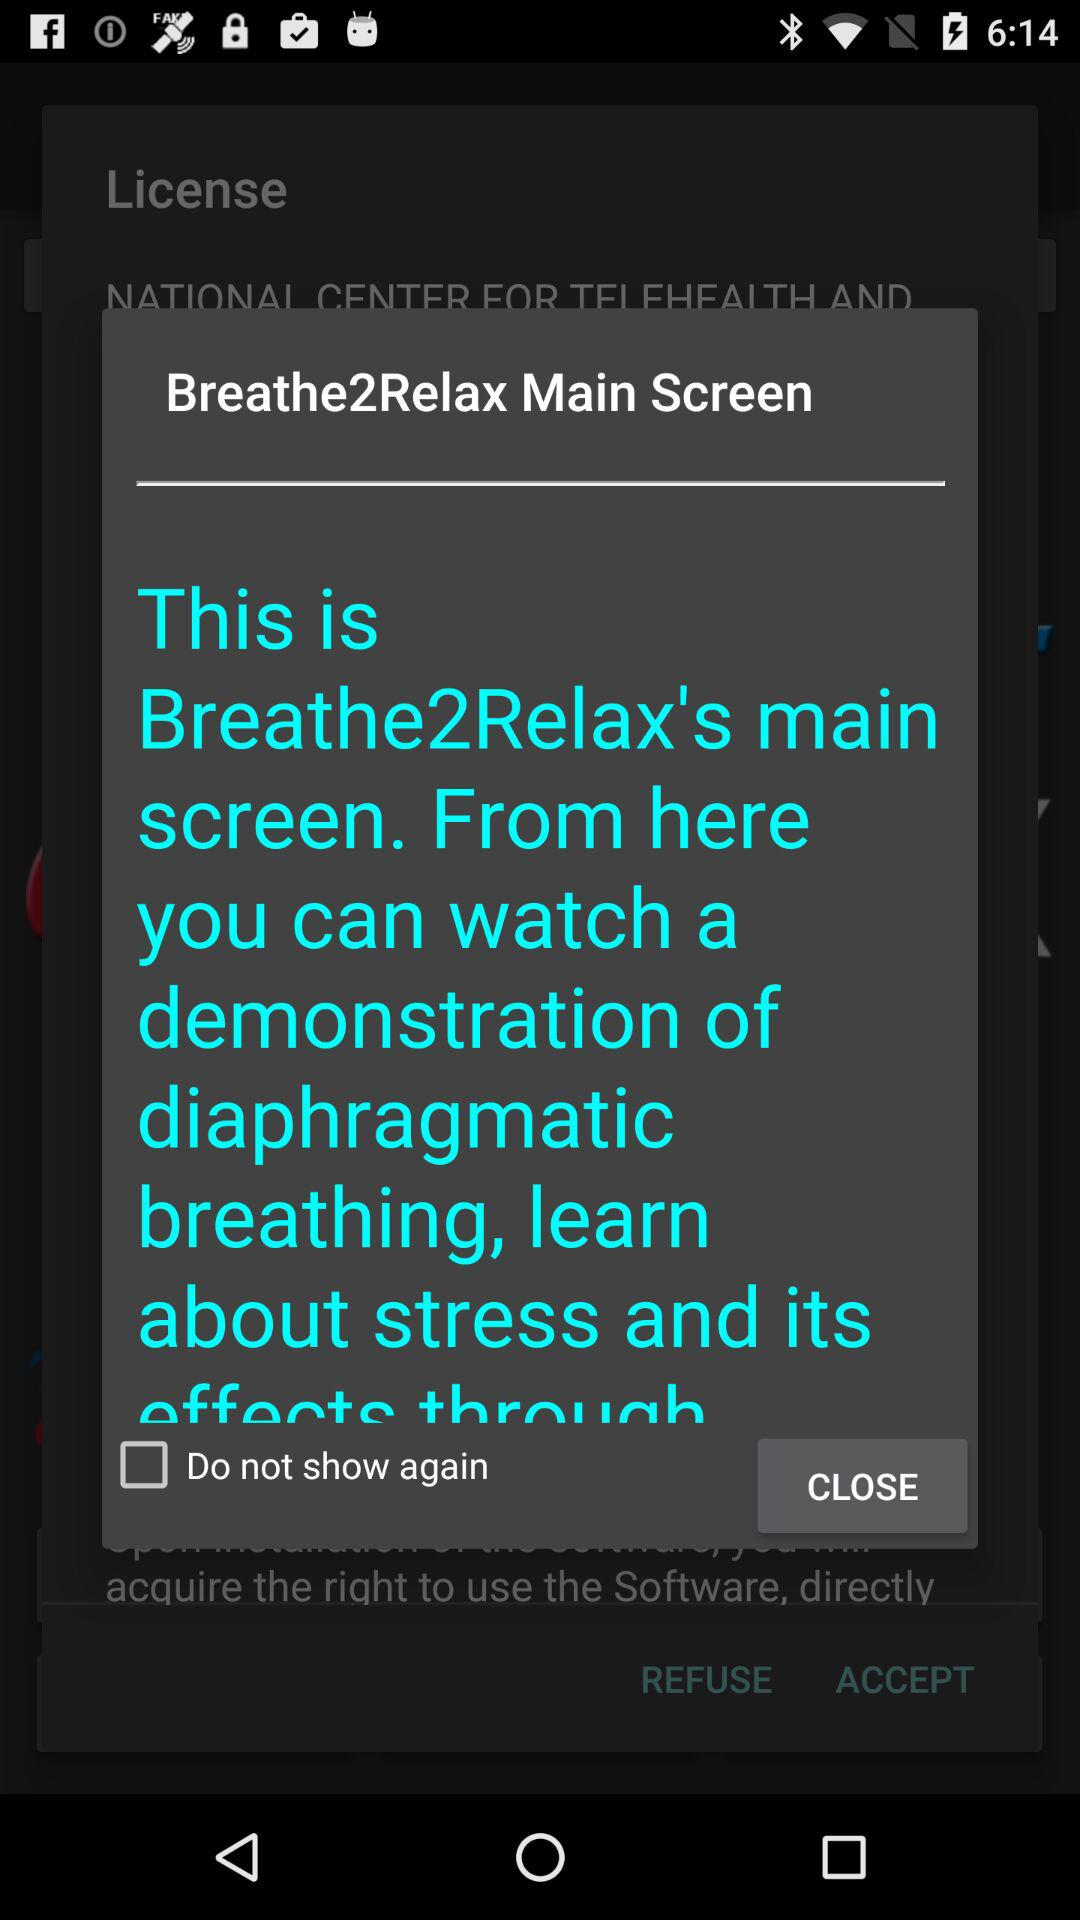What is the status of "Do not show again"? The status of "Do not show again" is "off". 